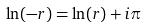Convert formula to latex. <formula><loc_0><loc_0><loc_500><loc_500>\ln ( - r ) = \ln ( r ) + i \pi</formula> 